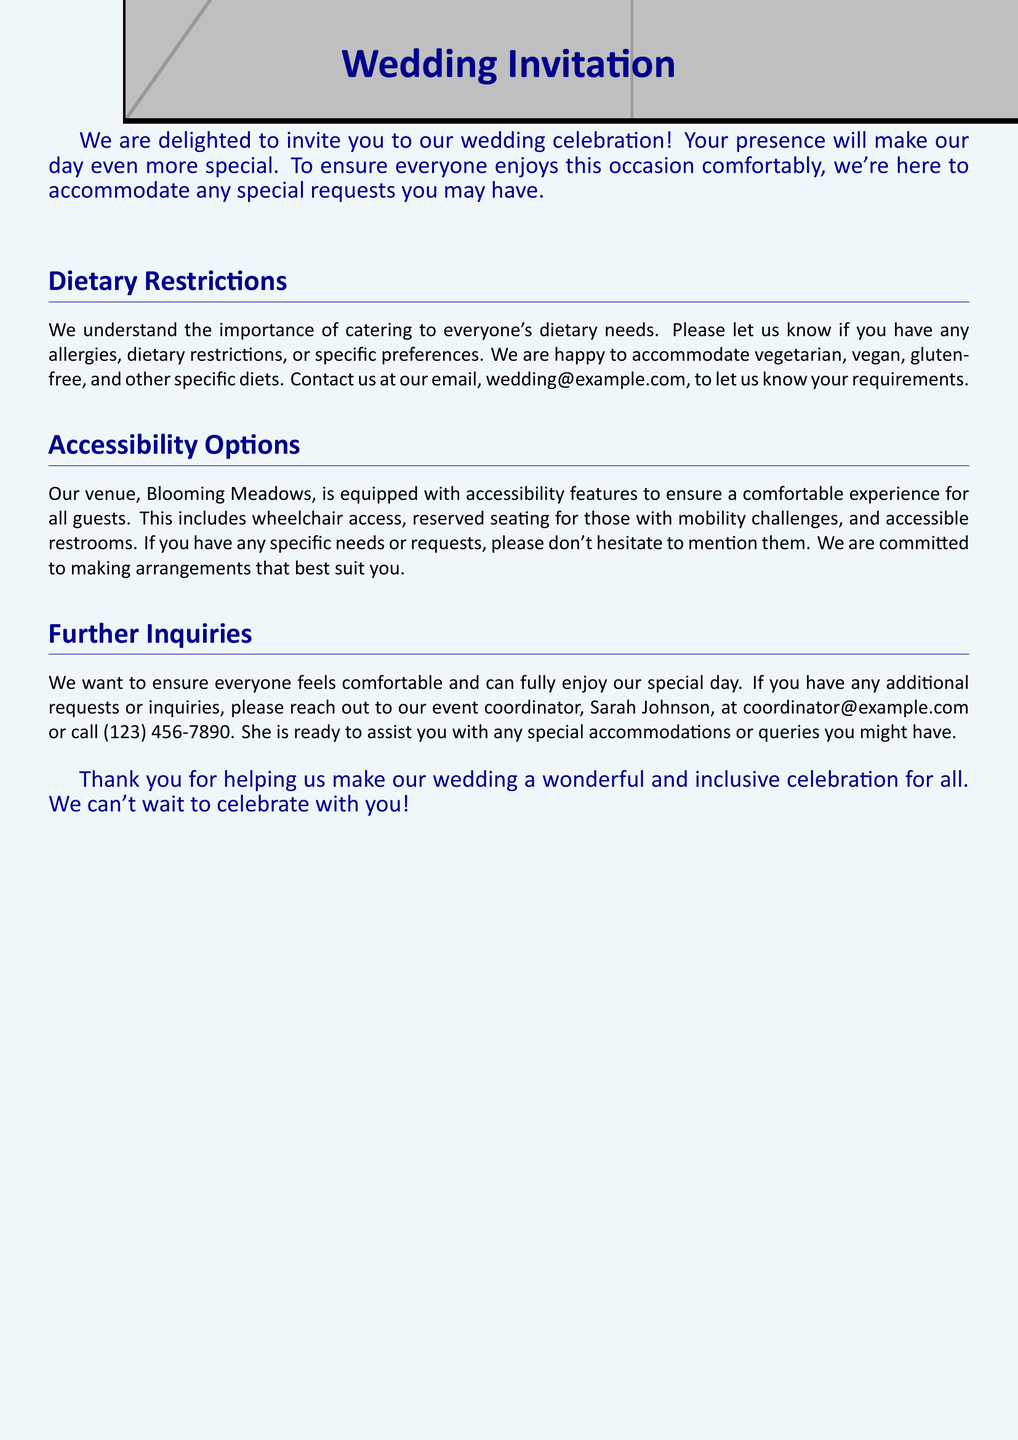What is the email for dietary restrictions? The email provided for notifying dietary restrictions is wedding@example.com.
Answer: wedding@example.com What is the name of the event coordinator? The document states the event coordinator's name is Sarah Johnson.
Answer: Sarah Johnson Is there wheelchair access at the venue? The document mentions that the venue includes accessibility features, which will ensure wheelchair access.
Answer: Yes What is the phone number for further inquiries? The phone number provided for further inquiries is (123) 456-7890.
Answer: (123) 456-7890 How are special requests accommodated according to the invitation? The invitation specifies that dietary needs, allergies, and specific preferences will be accommodated.
Answer: Dietary needs and preferences What is the purpose of this document? The main purpose of the document is to extend an invitation to a wedding celebration and ensure guest comfort.
Answer: Wedding invitation Which dietary options are mentioned? The document mentions vegetarian, vegan, and gluten-free as dietary options.
Answer: Vegetarian, vegan, gluten-free Where is the wedding venue? The name of the wedding venue mentioned in the document is Blooming Meadows.
Answer: Blooming Meadows 